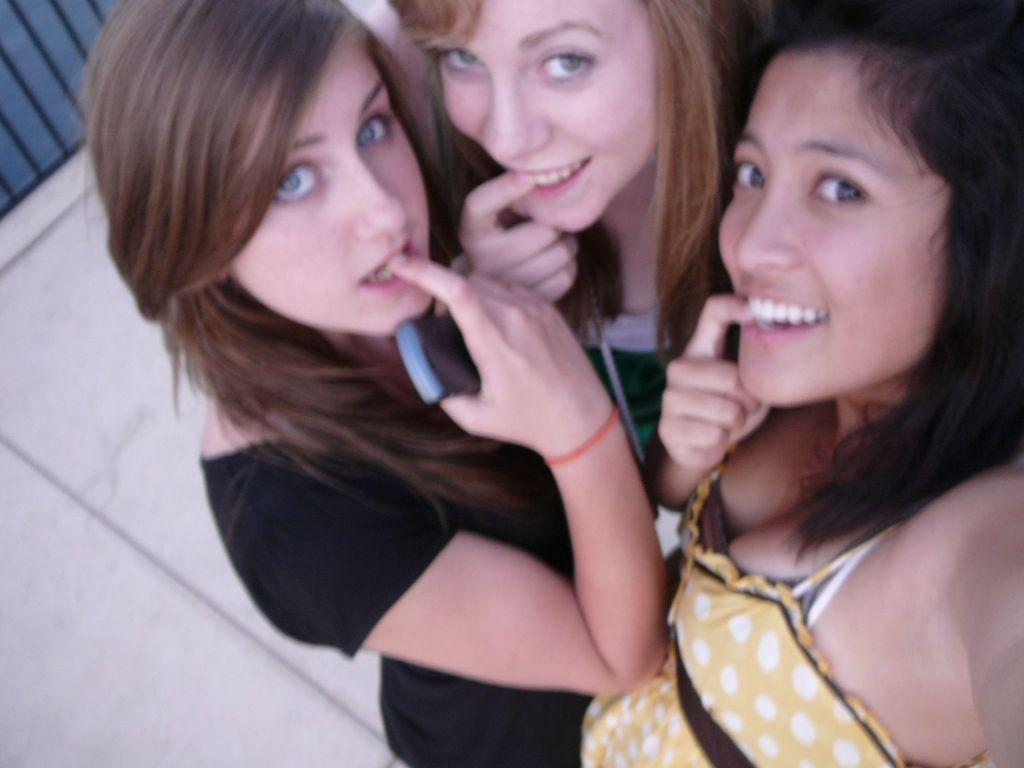How many people are in the image? There are a few people in the image. What can be seen beneath the people in the image? The ground is visible in the image. What objects are located in the top left corner of the image? There are black colored rods in the top left corner of the image. What type of button can be seen on the people's clothing in the image? There is no button visible on the people's clothing in the image. How much salt is present in the image? There is no salt present in the image. 